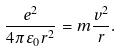Convert formula to latex. <formula><loc_0><loc_0><loc_500><loc_500>\frac { e ^ { 2 } } { 4 \pi \varepsilon _ { 0 } r ^ { 2 } } = m \frac { v ^ { 2 } } { r } .</formula> 